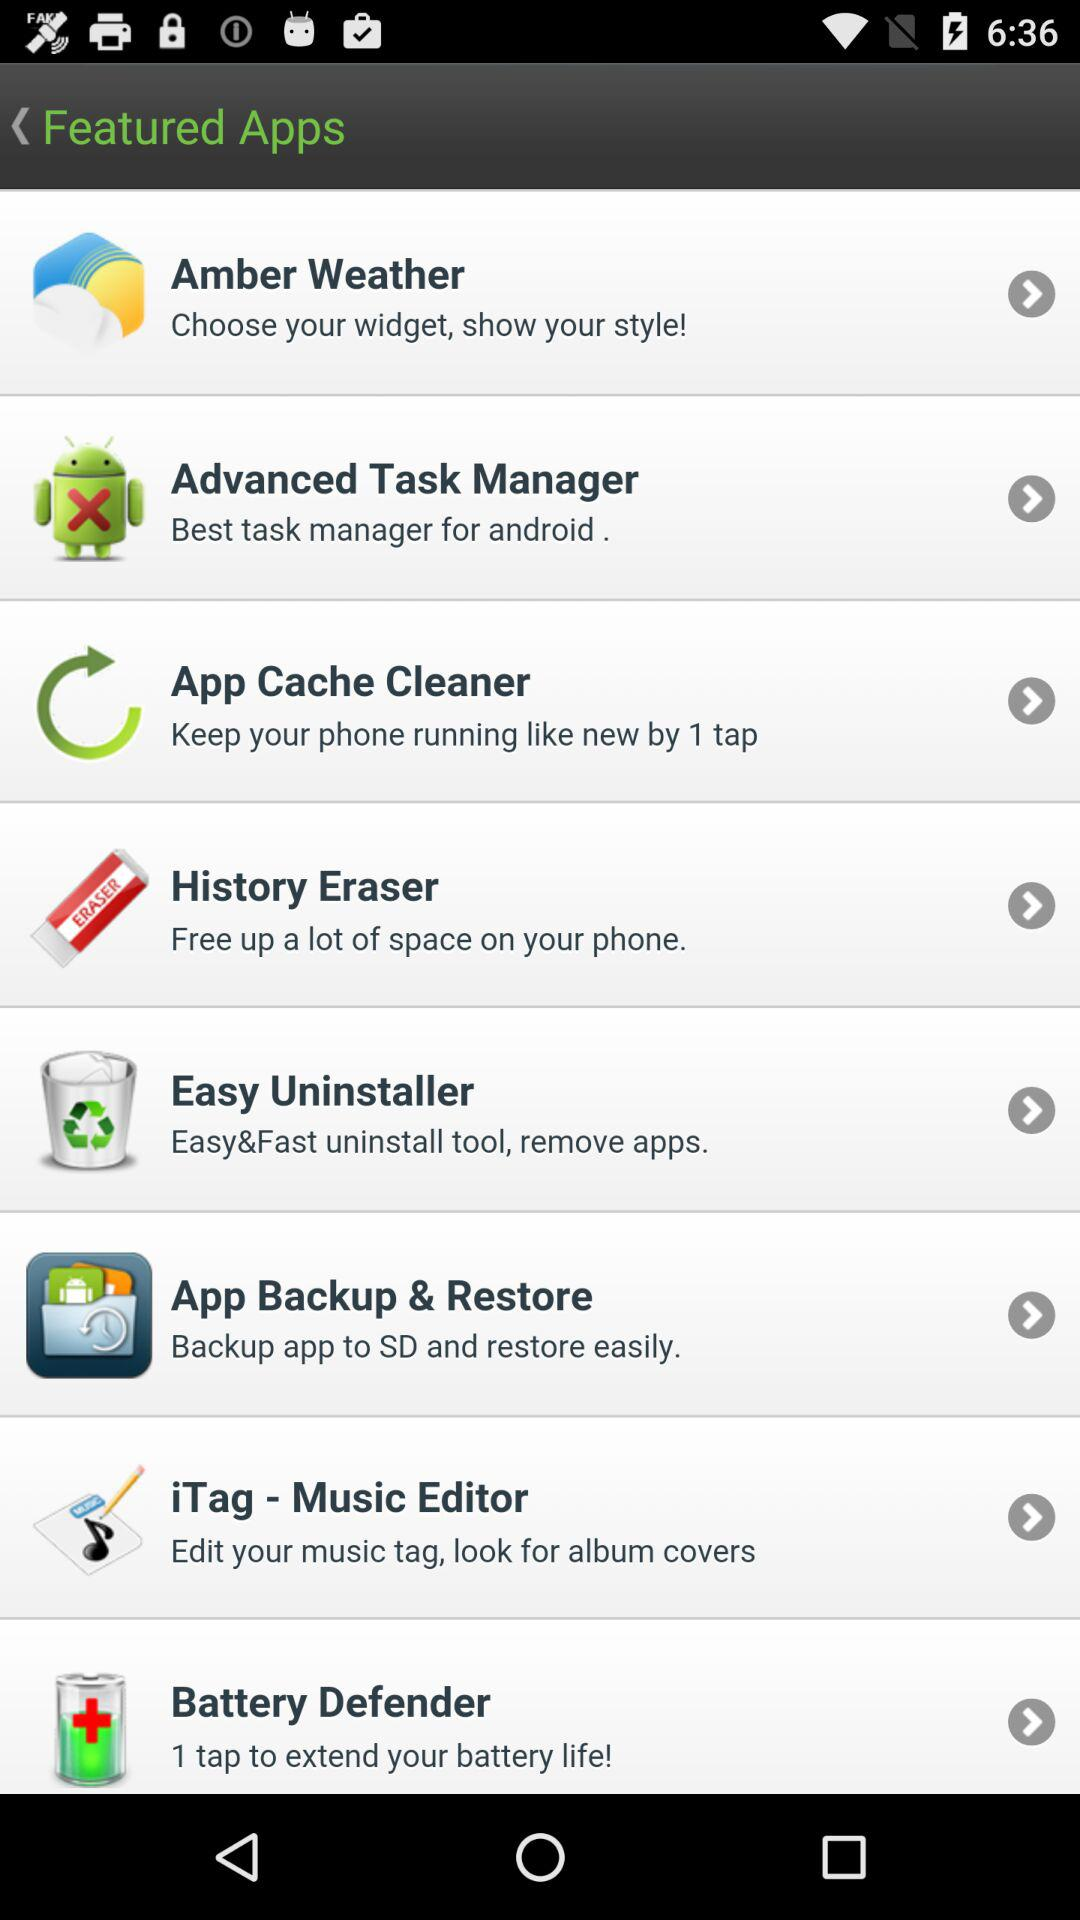What app can we use to "Backup app to SD and restore easily"? You can use "App Backup & Restore". 